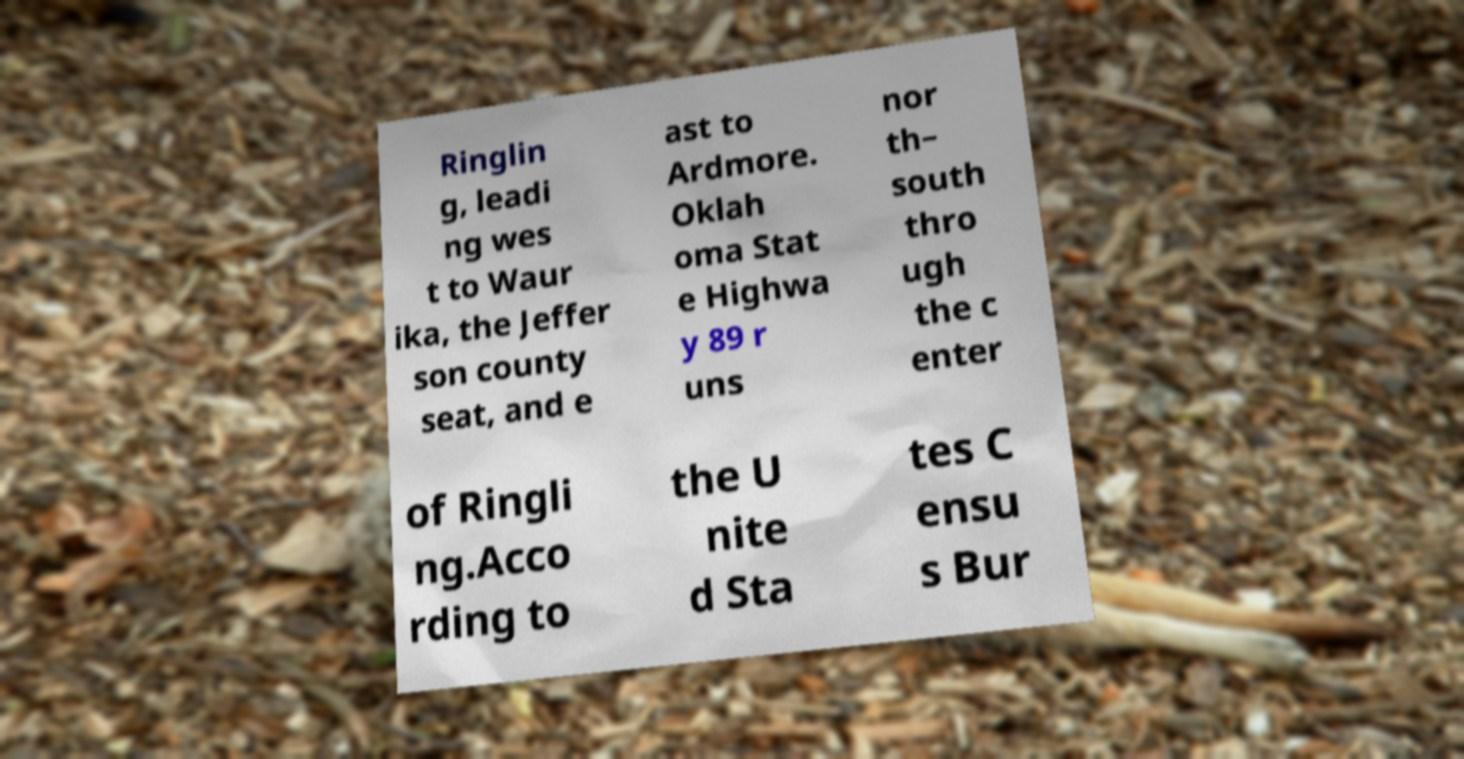Please identify and transcribe the text found in this image. Ringlin g, leadi ng wes t to Waur ika, the Jeffer son county seat, and e ast to Ardmore. Oklah oma Stat e Highwa y 89 r uns nor th– south thro ugh the c enter of Ringli ng.Acco rding to the U nite d Sta tes C ensu s Bur 